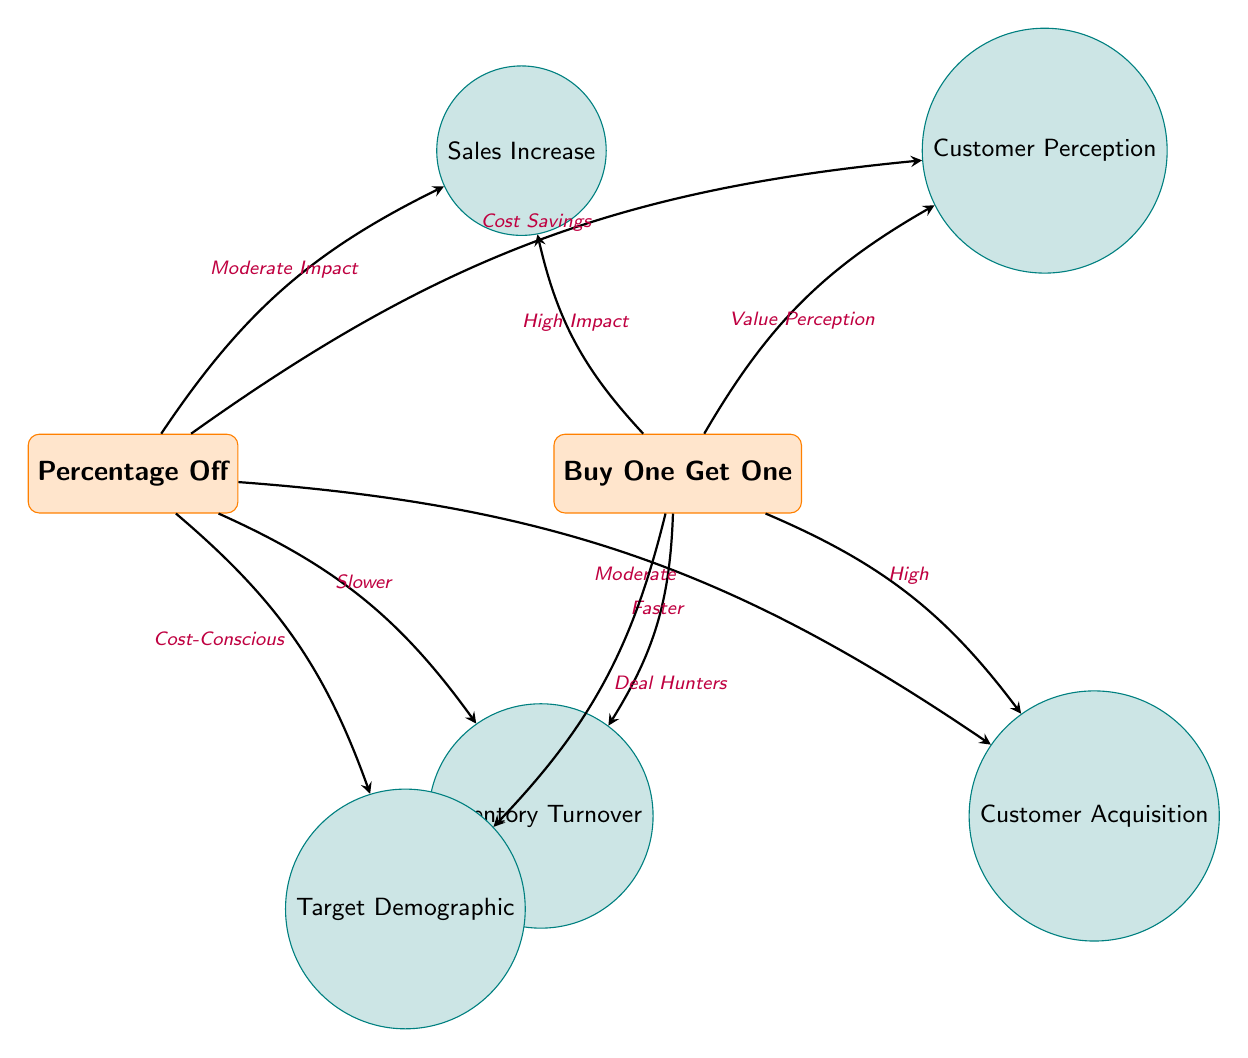What are the two discount strategies depicted in the diagram? The two discount strategies represented in the diagram are located as the primary nodes at the top: "Percentage Off" and "Buy One Get One".
Answer: Percentage Off, Buy One Get One What factors are linked to the "Buy One Get One" strategy? The "Buy One Get One" strategy has three factors directly linked: "Sales Increase," "Customer Perception," and "Inventory Turnover."
Answer: Sales Increase, Customer Perception, Inventory Turnover Which discount strategy has a "High Impact" on sales increase? The diagram clearly indicates that the "Buy One Get One" strategy is described as having a "High Impact" on sales increase.
Answer: Buy One Get One What type of customer is more targeted by the "Percentage Off" strategy? According to the diagram, the "Percentage Off" strategy targets "Cost-Conscious" customers as indicated by its connection to the "Target Demographic."
Answer: Cost-Conscious Which strategy is said to have a faster inventory turnover? The diagram notes that the "Buy One Get One" strategy is associated with faster inventory turnover, as shown in its relationship to the "Inventory Turnover" factor.
Answer: Buy One Get One What is the customer perception associated with the "Percentage Off" strategy? The "Percentage Off" strategy's associated customer perception is described as "Cost Savings," based on the diagram's connection to that factor.
Answer: Cost Savings How many factors are linked to both discount strategies? The diagram displays a total of five different factors that are linked to both discount strategies when combined: "Sales Increase," "Customer Perception," "Inventory Turnover," "Customer Acquisition," and "Target Demographic."
Answer: Five What is the impact on customer acquisition associated with "Buy One Get One"? The "Buy One Get One" strategy is linked to "High" customer acquisition according to the diagram, emphasizing its effectiveness in attracting customers.
Answer: High 